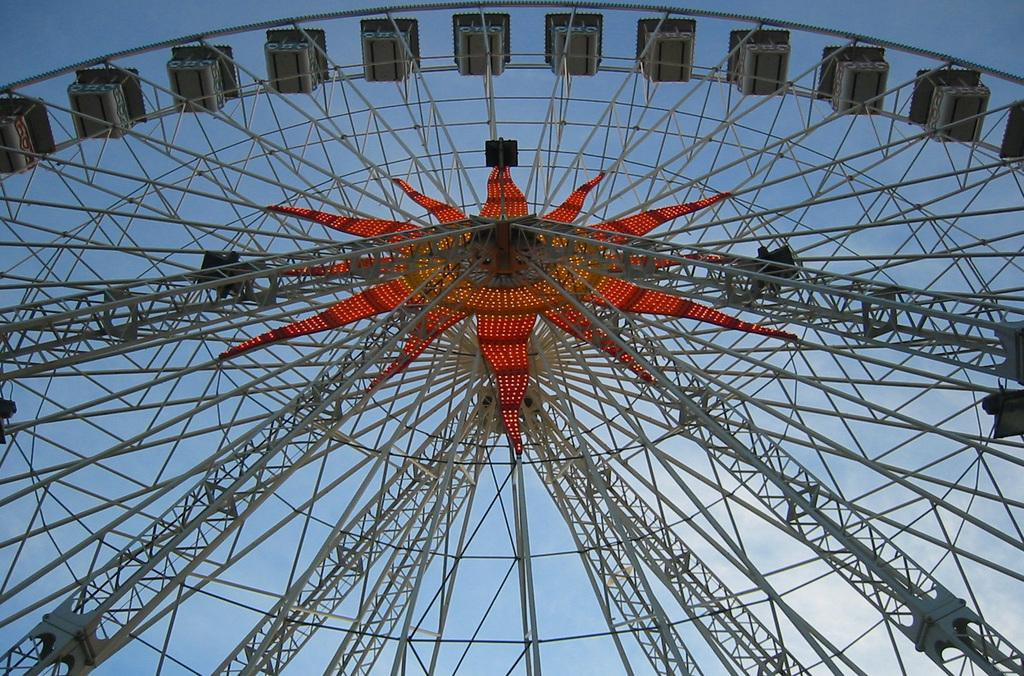What is the main subject of the image? The main subject of the image is a giant wheel. What can be seen in the background of the image? The sky is visible in the background of the image. How many ghosts are sitting on the giant wheel in the image? There are no ghosts present in the image; it only features a giant wheel and the sky in the background. 